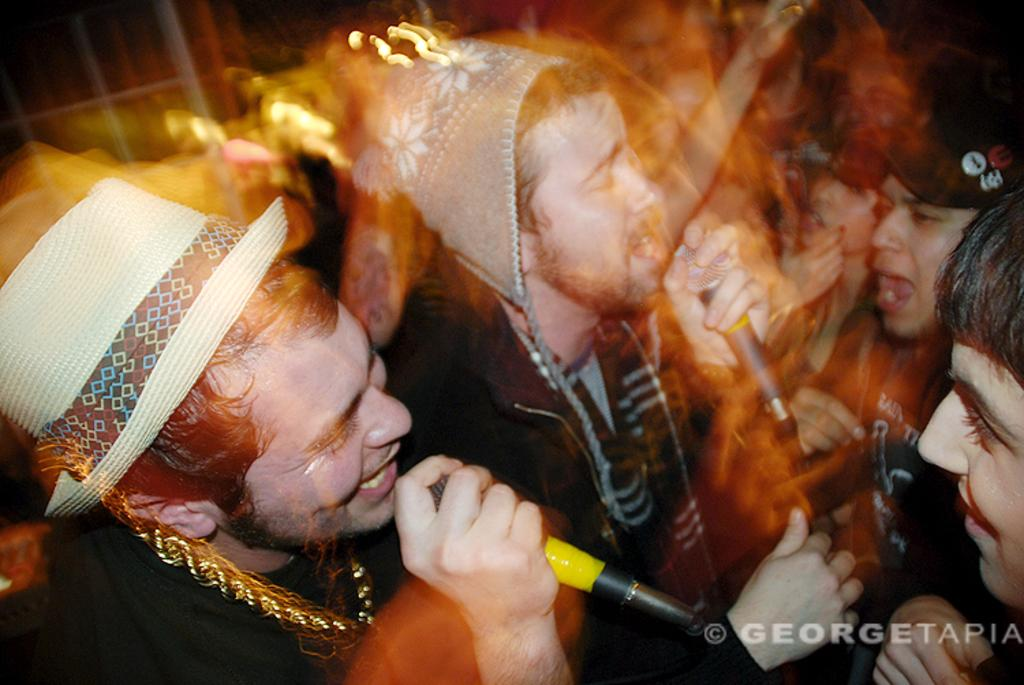What are the two persons in the image doing? The two persons are standing and holding microphones, and they are singing. Are there any other people in the image besides the two singers? Yes, there is a group of people standing nearby. What can be found at the bottom right of the image? There is text at the bottom right of the image. What type of payment is being made to the singers in the image? There is no indication of payment being made in the image; it only shows the two singers holding microphones and singing. 